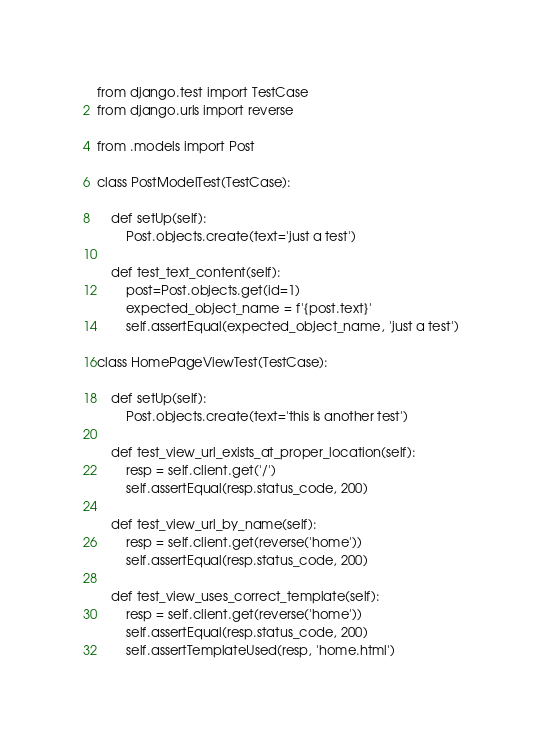Convert code to text. <code><loc_0><loc_0><loc_500><loc_500><_Python_>from django.test import TestCase
from django.urls import reverse

from .models import Post

class PostModelTest(TestCase):

    def setUp(self):
        Post.objects.create(text='just a test')

    def test_text_content(self):
        post=Post.objects.get(id=1)
        expected_object_name = f'{post.text}'
        self.assertEqual(expected_object_name, 'just a test')

class HomePageViewTest(TestCase):

    def setUp(self):
        Post.objects.create(text='this is another test')

    def test_view_url_exists_at_proper_location(self):
        resp = self.client.get('/')
        self.assertEqual(resp.status_code, 200)

    def test_view_url_by_name(self):
        resp = self.client.get(reverse('home'))
        self.assertEqual(resp.status_code, 200)

    def test_view_uses_correct_template(self):
        resp = self.client.get(reverse('home'))
        self.assertEqual(resp.status_code, 200)
        self.assertTemplateUsed(resp, 'home.html')
</code> 